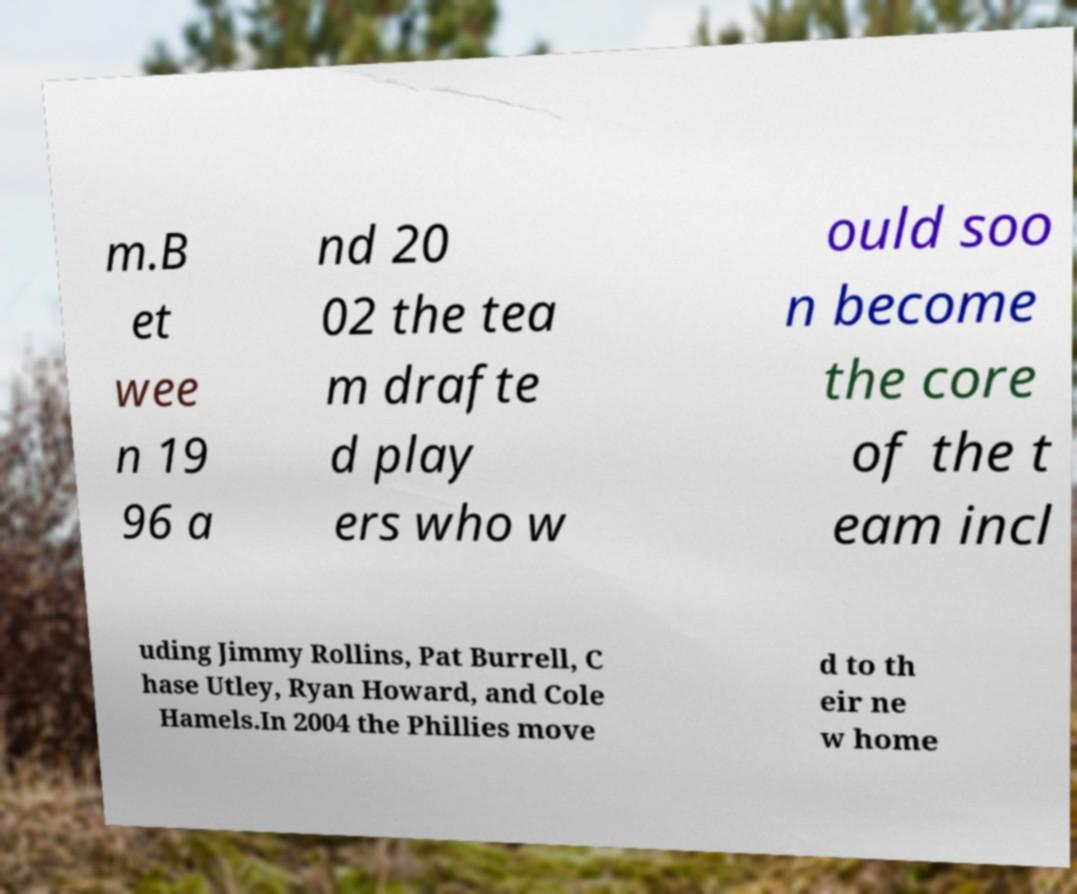What messages or text are displayed in this image? I need them in a readable, typed format. m.B et wee n 19 96 a nd 20 02 the tea m drafte d play ers who w ould soo n become the core of the t eam incl uding Jimmy Rollins, Pat Burrell, C hase Utley, Ryan Howard, and Cole Hamels.In 2004 the Phillies move d to th eir ne w home 